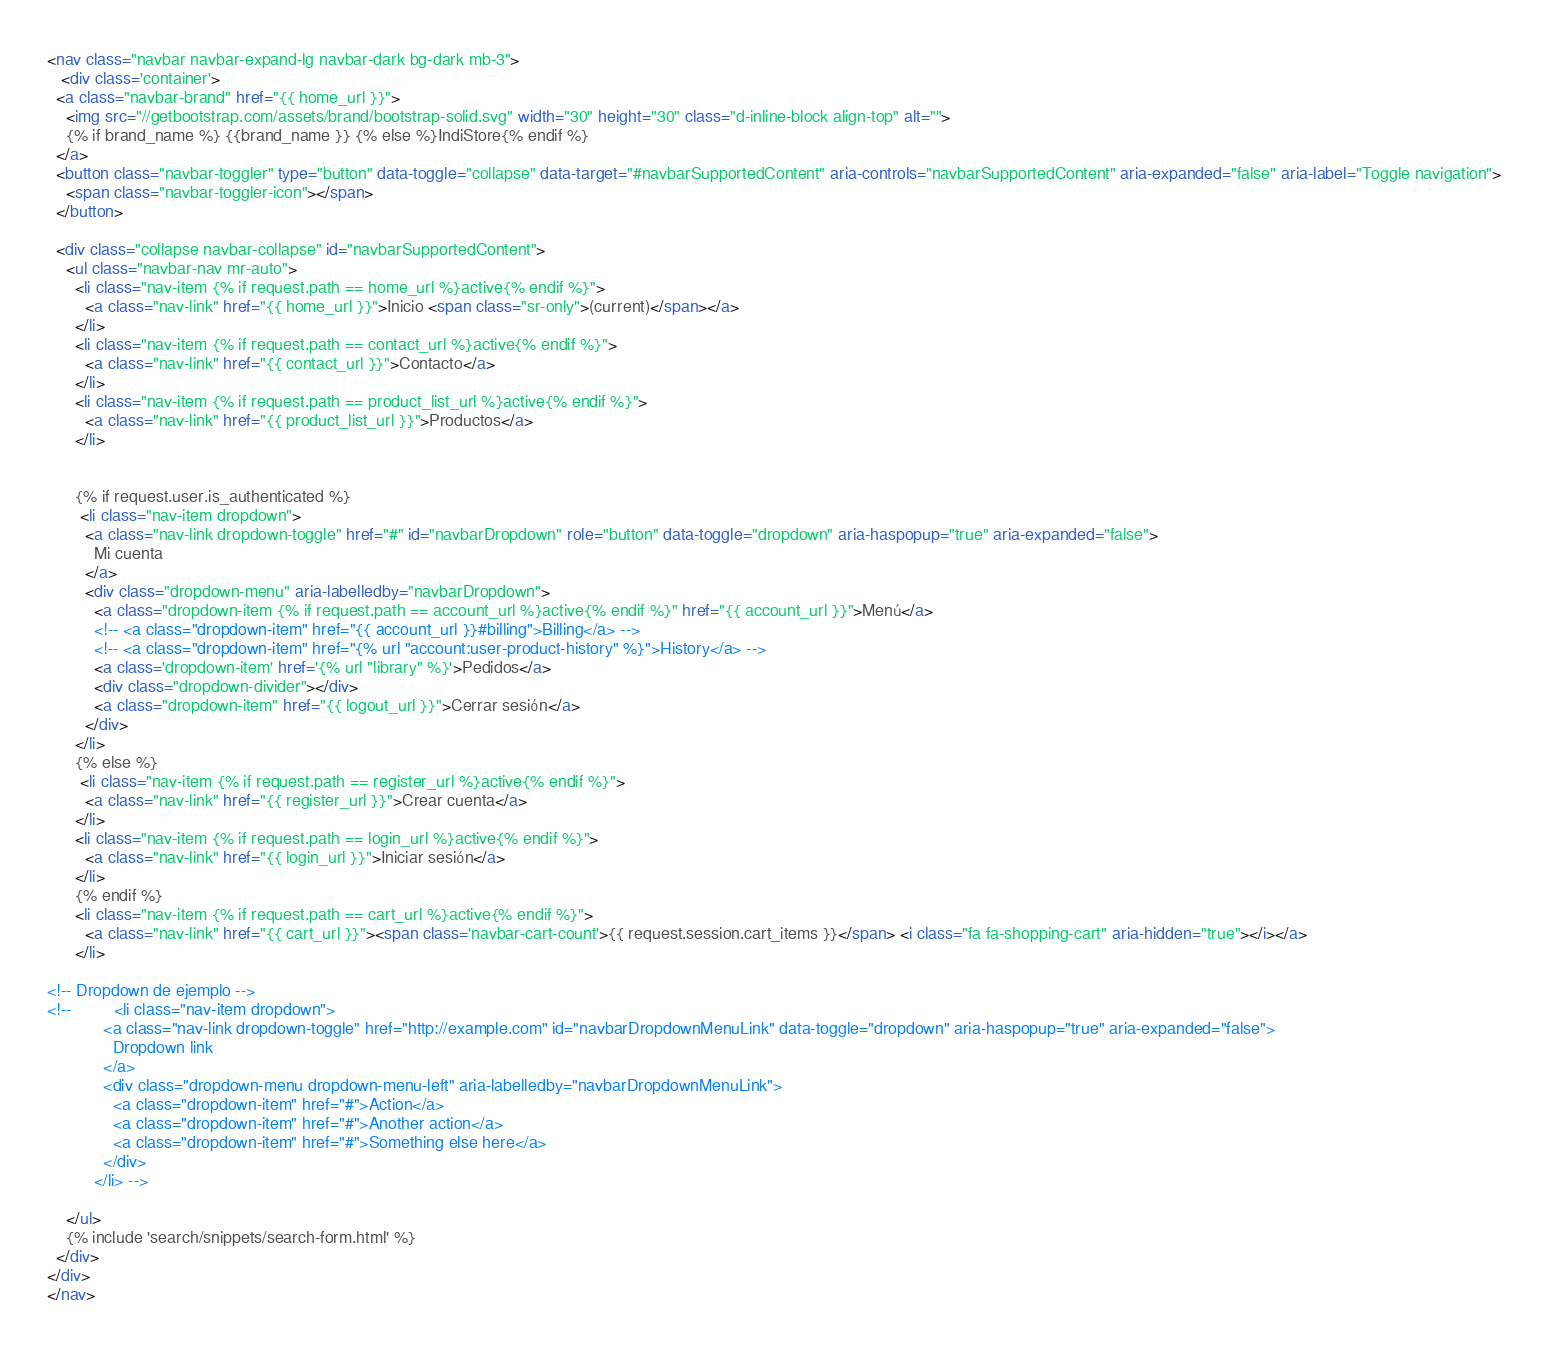Convert code to text. <code><loc_0><loc_0><loc_500><loc_500><_HTML_><nav class="navbar navbar-expand-lg navbar-dark bg-dark mb-3">
   <div class='container'>
  <a class="navbar-brand" href="{{ home_url }}">
    <img src="//getbootstrap.com/assets/brand/bootstrap-solid.svg" width="30" height="30" class="d-inline-block align-top" alt="">
    {% if brand_name %} {{brand_name }} {% else %}IndiStore{% endif %}
  </a>
  <button class="navbar-toggler" type="button" data-toggle="collapse" data-target="#navbarSupportedContent" aria-controls="navbarSupportedContent" aria-expanded="false" aria-label="Toggle navigation">
    <span class="navbar-toggler-icon"></span>
  </button>

  <div class="collapse navbar-collapse" id="navbarSupportedContent">
    <ul class="navbar-nav mr-auto">
      <li class="nav-item {% if request.path == home_url %}active{% endif %}">
        <a class="nav-link" href="{{ home_url }}">Inicio <span class="sr-only">(current)</span></a>
      </li>
      <li class="nav-item {% if request.path == contact_url %}active{% endif %}">
        <a class="nav-link" href="{{ contact_url }}">Contacto</a>
      </li>
      <li class="nav-item {% if request.path == product_list_url %}active{% endif %}">
        <a class="nav-link" href="{{ product_list_url }}">Productos</a>
      </li>


      {% if request.user.is_authenticated %}
       <li class="nav-item dropdown">
        <a class="nav-link dropdown-toggle" href="#" id="navbarDropdown" role="button" data-toggle="dropdown" aria-haspopup="true" aria-expanded="false">
          Mi cuenta
        </a>
        <div class="dropdown-menu" aria-labelledby="navbarDropdown">
          <a class="dropdown-item {% if request.path == account_url %}active{% endif %}" href="{{ account_url }}">Menú</a>
          <!-- <a class="dropdown-item" href="{{ account_url }}#billing">Billing</a> -->
          <!-- <a class="dropdown-item" href="{% url "account:user-product-history" %}">History</a> -->
          <a class='dropdown-item' href='{% url "library" %}'>Pedidos</a>
          <div class="dropdown-divider"></div>
          <a class="dropdown-item" href="{{ logout_url }}">Cerrar sesión</a>
        </div>
      </li>
      {% else %}
       <li class="nav-item {% if request.path == register_url %}active{% endif %}">
        <a class="nav-link" href="{{ register_url }}">Crear cuenta</a>
      </li>
      <li class="nav-item {% if request.path == login_url %}active{% endif %}">
        <a class="nav-link" href="{{ login_url }}">Iniciar sesión</a>
      </li>
      {% endif %}
      <li class="nav-item {% if request.path == cart_url %}active{% endif %}">
        <a class="nav-link" href="{{ cart_url }}"><span class='navbar-cart-count'>{{ request.session.cart_items }}</span> <i class="fa fa-shopping-cart" aria-hidden="true"></i></a>
      </li>

<!-- Dropdown de ejemplo -->
<!--         <li class="nav-item dropdown">
            <a class="nav-link dropdown-toggle" href="http://example.com" id="navbarDropdownMenuLink" data-toggle="dropdown" aria-haspopup="true" aria-expanded="false">
              Dropdown link
            </a>
            <div class="dropdown-menu dropdown-menu-left" aria-labelledby="navbarDropdownMenuLink">
              <a class="dropdown-item" href="#">Action</a>
              <a class="dropdown-item" href="#">Another action</a>
              <a class="dropdown-item" href="#">Something else here</a>
            </div>
          </li> -->

    </ul>
    {% include 'search/snippets/search-form.html' %}
  </div>
</div>
</nav></code> 